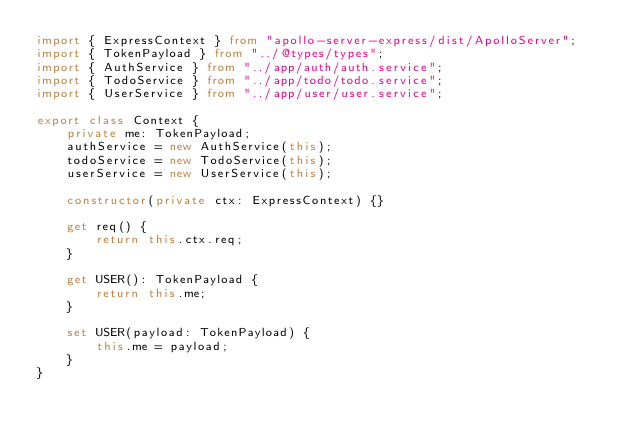Convert code to text. <code><loc_0><loc_0><loc_500><loc_500><_TypeScript_>import { ExpressContext } from "apollo-server-express/dist/ApolloServer";
import { TokenPayload } from "../@types/types";
import { AuthService } from "../app/auth/auth.service";
import { TodoService } from "../app/todo/todo.service";
import { UserService } from "../app/user/user.service";

export class Context {
    private me: TokenPayload;
    authService = new AuthService(this);
    todoService = new TodoService(this);
    userService = new UserService(this);

    constructor(private ctx: ExpressContext) {}

    get req() {
        return this.ctx.req;
    }

    get USER(): TokenPayload {
        return this.me;
    }

    set USER(payload: TokenPayload) {
        this.me = payload;
    }
}
</code> 